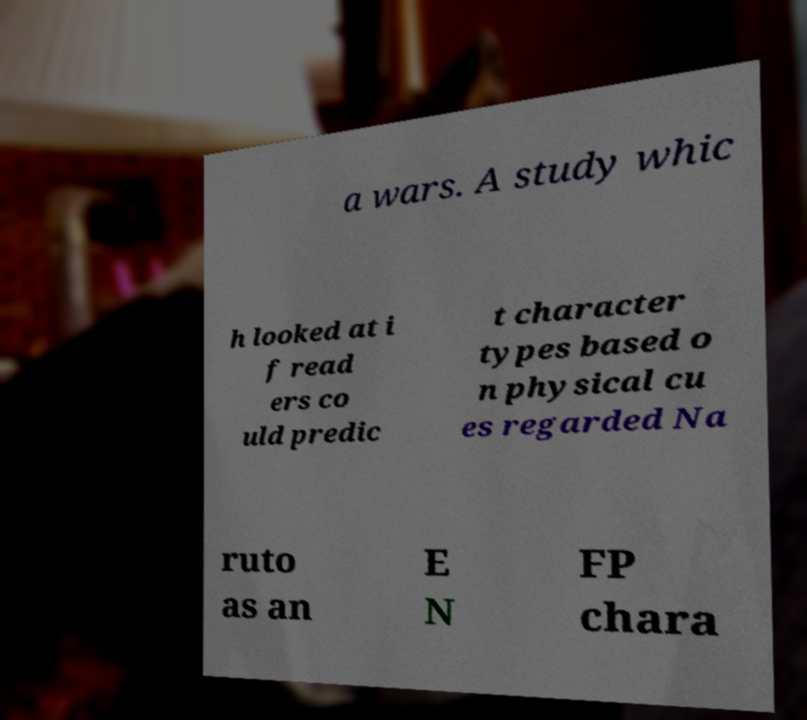Could you assist in decoding the text presented in this image and type it out clearly? a wars. A study whic h looked at i f read ers co uld predic t character types based o n physical cu es regarded Na ruto as an E N FP chara 